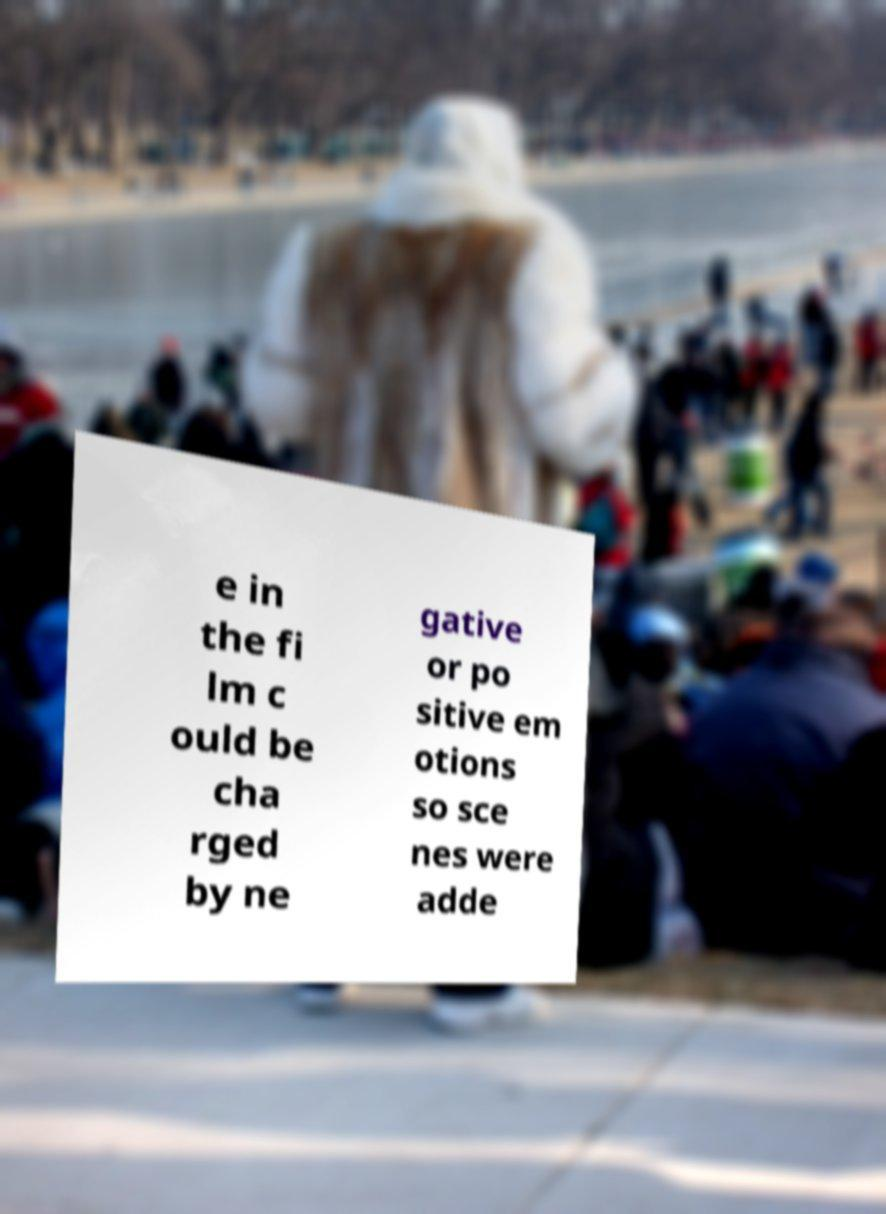There's text embedded in this image that I need extracted. Can you transcribe it verbatim? e in the fi lm c ould be cha rged by ne gative or po sitive em otions so sce nes were adde 